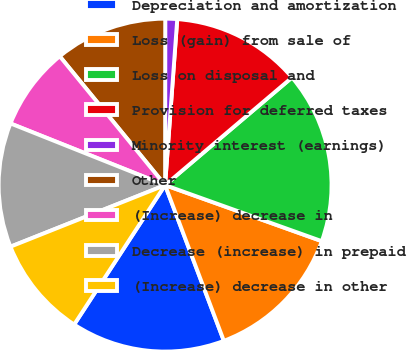Convert chart to OTSL. <chart><loc_0><loc_0><loc_500><loc_500><pie_chart><fcel>Depreciation and amortization<fcel>Loss (gain) from sale of<fcel>Loss on disposal and<fcel>Provision for deferred taxes<fcel>Minority interest (earnings)<fcel>Other<fcel>(Increase) decrease in<fcel>Decrease (increase) in prepaid<fcel>(Increase) decrease in other<nl><fcel>14.94%<fcel>13.79%<fcel>16.66%<fcel>12.64%<fcel>1.15%<fcel>10.92%<fcel>8.05%<fcel>12.07%<fcel>9.77%<nl></chart> 